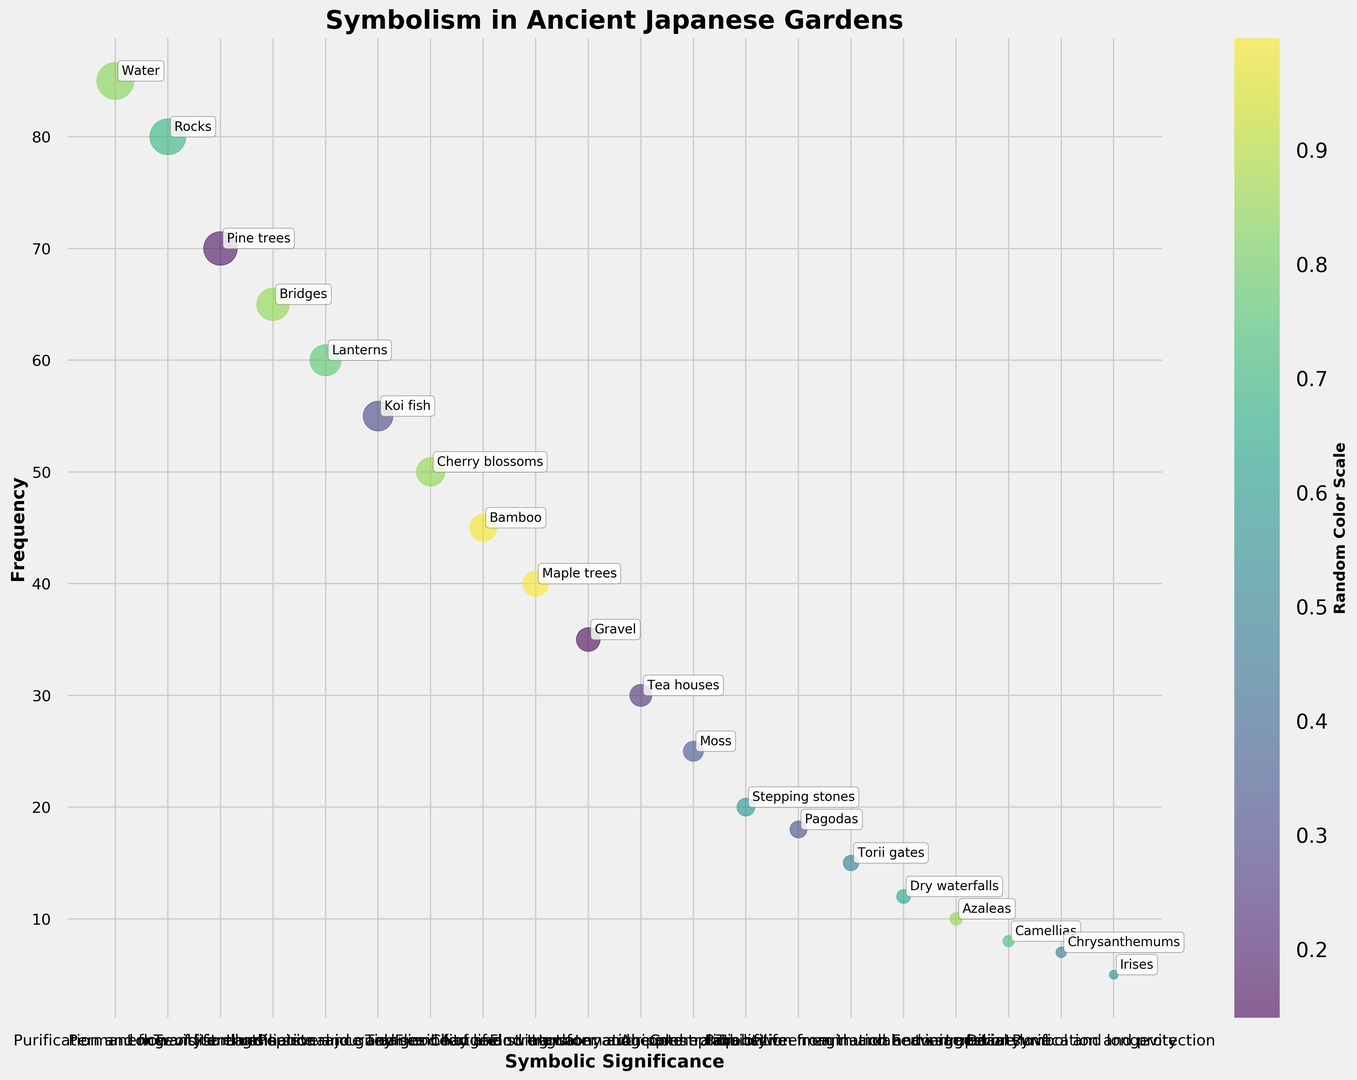What is the most frequently occurring symbolic element in the figure? The size of the bubbles indicates frequency. The largest bubble corresponds to "Water" with a frequency of 85.
Answer: Water Which symbolic element has a higher frequency, Rocks or Lanterns? By comparing the sizes of their respective bubbles, "Rocks" has a frequency of 80 while "Lanterns" has a frequency of 60. Therefore, "Rocks" is higher.
Answer: Rocks What is the average frequency of Pine Trees, Bridges, and Lanterns? Add their frequencies: 70 (Pine Trees) + 65 (Bridges) + 60 (Lanterns) = 195. Then, divide by the number of elements, which is 3. 195 / 3 = 65.
Answer: 65 What is the significance associated with the symbolic element, Cherry Blossoms? Identify Cherry Blossoms in the figure and read its associated significance, which is "Transience of life".
Answer: Transience of life Are Koi Fish's bubble size and Maple Trees' bubble size equal? Compare the sizes of Koi Fish and Maple Trees bubbles. Koi Fish has a frequency of 55, while Maple Trees have a frequency of 40. Bubble sizes are not equal.
Answer: No Which symbolic element represents the least frequent in the figure and what is its frequency? Identify the smallest bubble in the figure, which corresponds to "Irises" with a frequency of 5.
Answer: Irises, 5 Which symbolic element is associated with "Transition and spiritual journey"? Identify the symbolic element next to the label "Transition and spiritual journey" in the figure, which is "Bridges".
Answer: Bridges How much larger is the bubble for Bamboo compared to the bubble for Tea Houses? Bamboo's frequency is 45, and Tea Houses' frequency is 30; the difference is 45 - 30 = 15.
Answer: 15 What is the sum of the frequencies of Moss, Stepping Stones, and Pagodas? Add their frequencies: 25 (Moss) + 20 (Stepping Stones) + 18 (Pagodas) = 63.
Answer: 63 Which has a greater frequency, the symbolic element representing "Imagination and suggestion" or the one representing "Divine love"? The symbolic element for "Imagination and suggestion" is Dry Waterfalls with a frequency of 12. For "Divine love," it is Camellias with a frequency of 8. Dry Waterfalls has a greater frequency.
Answer: Dry Waterfalls 